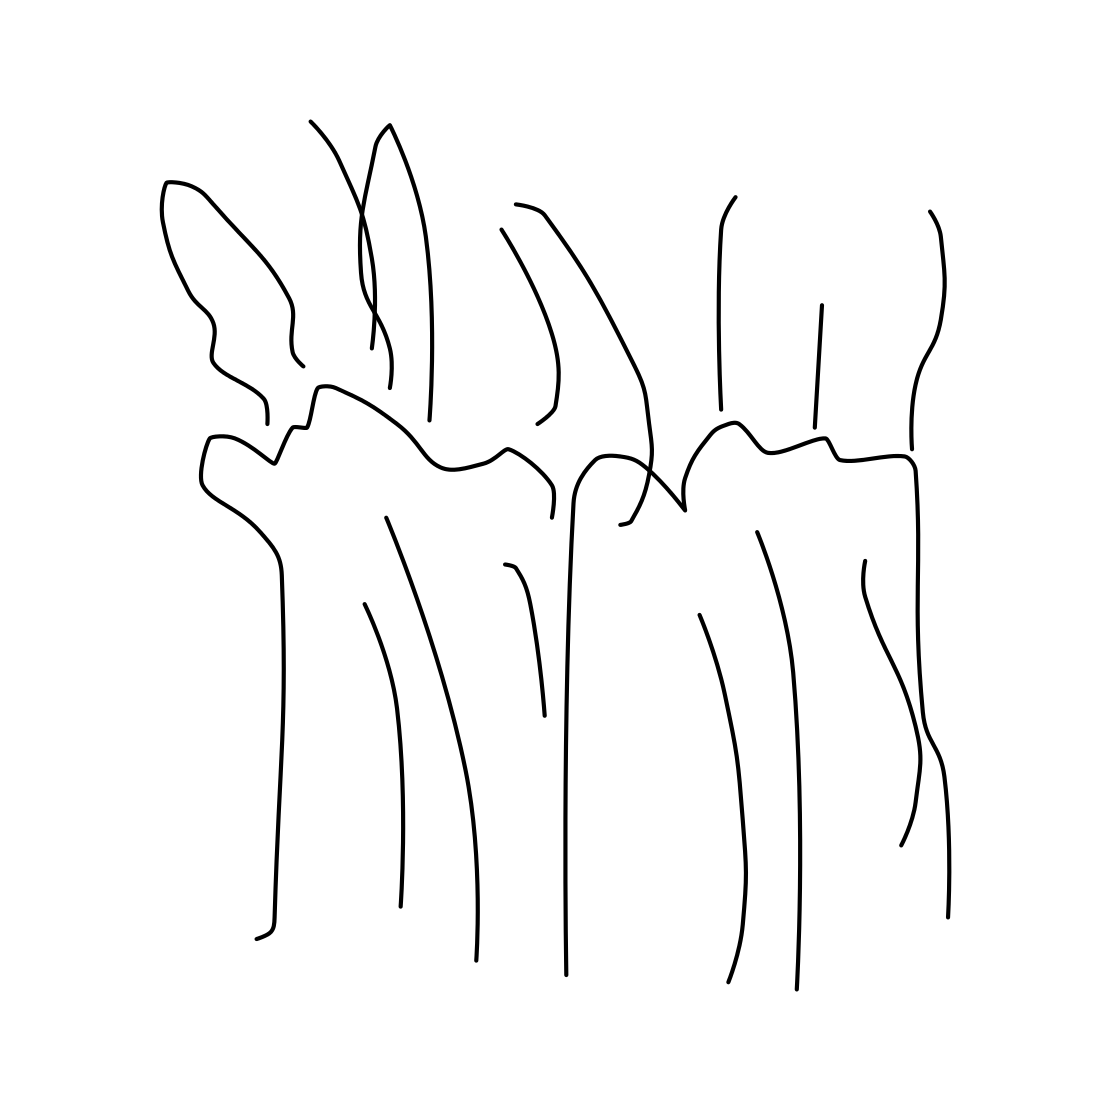What artistic techniques can you identify in this drawing? The artist has used clean, continuous lines with varying thickness to compose the shapes in the drawing. There is a focus on contour lines to define the shapes without any shading or texture, giving the artwork a minimalist and modern feel. The use of negative space is also quite prominent, as it plays a crucial role in the overall composition and interpretation of the scene. 